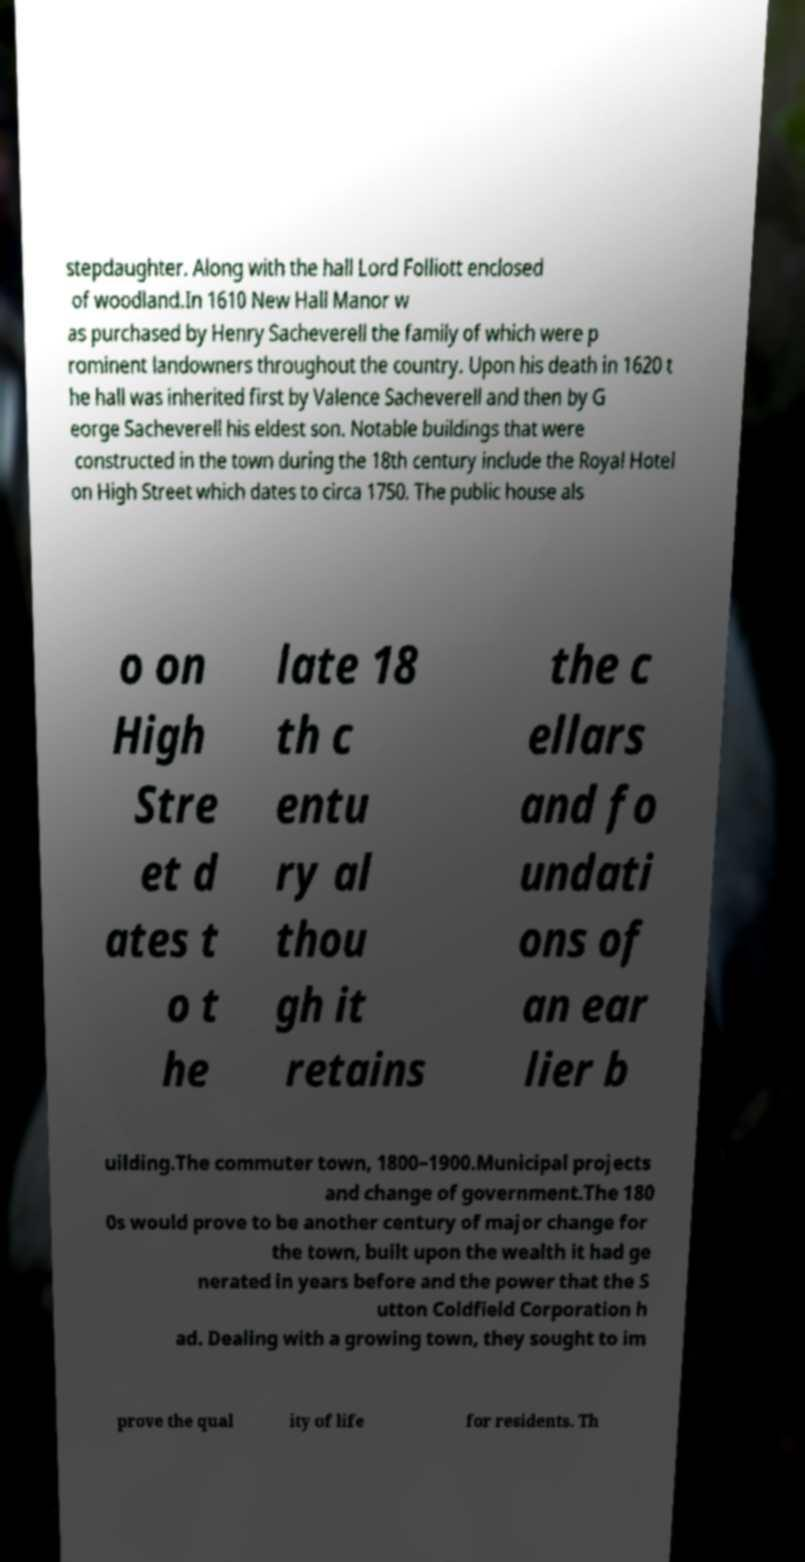There's text embedded in this image that I need extracted. Can you transcribe it verbatim? stepdaughter. Along with the hall Lord Folliott enclosed of woodland.In 1610 New Hall Manor w as purchased by Henry Sacheverell the family of which were p rominent landowners throughout the country. Upon his death in 1620 t he hall was inherited first by Valence Sacheverell and then by G eorge Sacheverell his eldest son. Notable buildings that were constructed in the town during the 18th century include the Royal Hotel on High Street which dates to circa 1750. The public house als o on High Stre et d ates t o t he late 18 th c entu ry al thou gh it retains the c ellars and fo undati ons of an ear lier b uilding.The commuter town, 1800–1900.Municipal projects and change of government.The 180 0s would prove to be another century of major change for the town, built upon the wealth it had ge nerated in years before and the power that the S utton Coldfield Corporation h ad. Dealing with a growing town, they sought to im prove the qual ity of life for residents. Th 